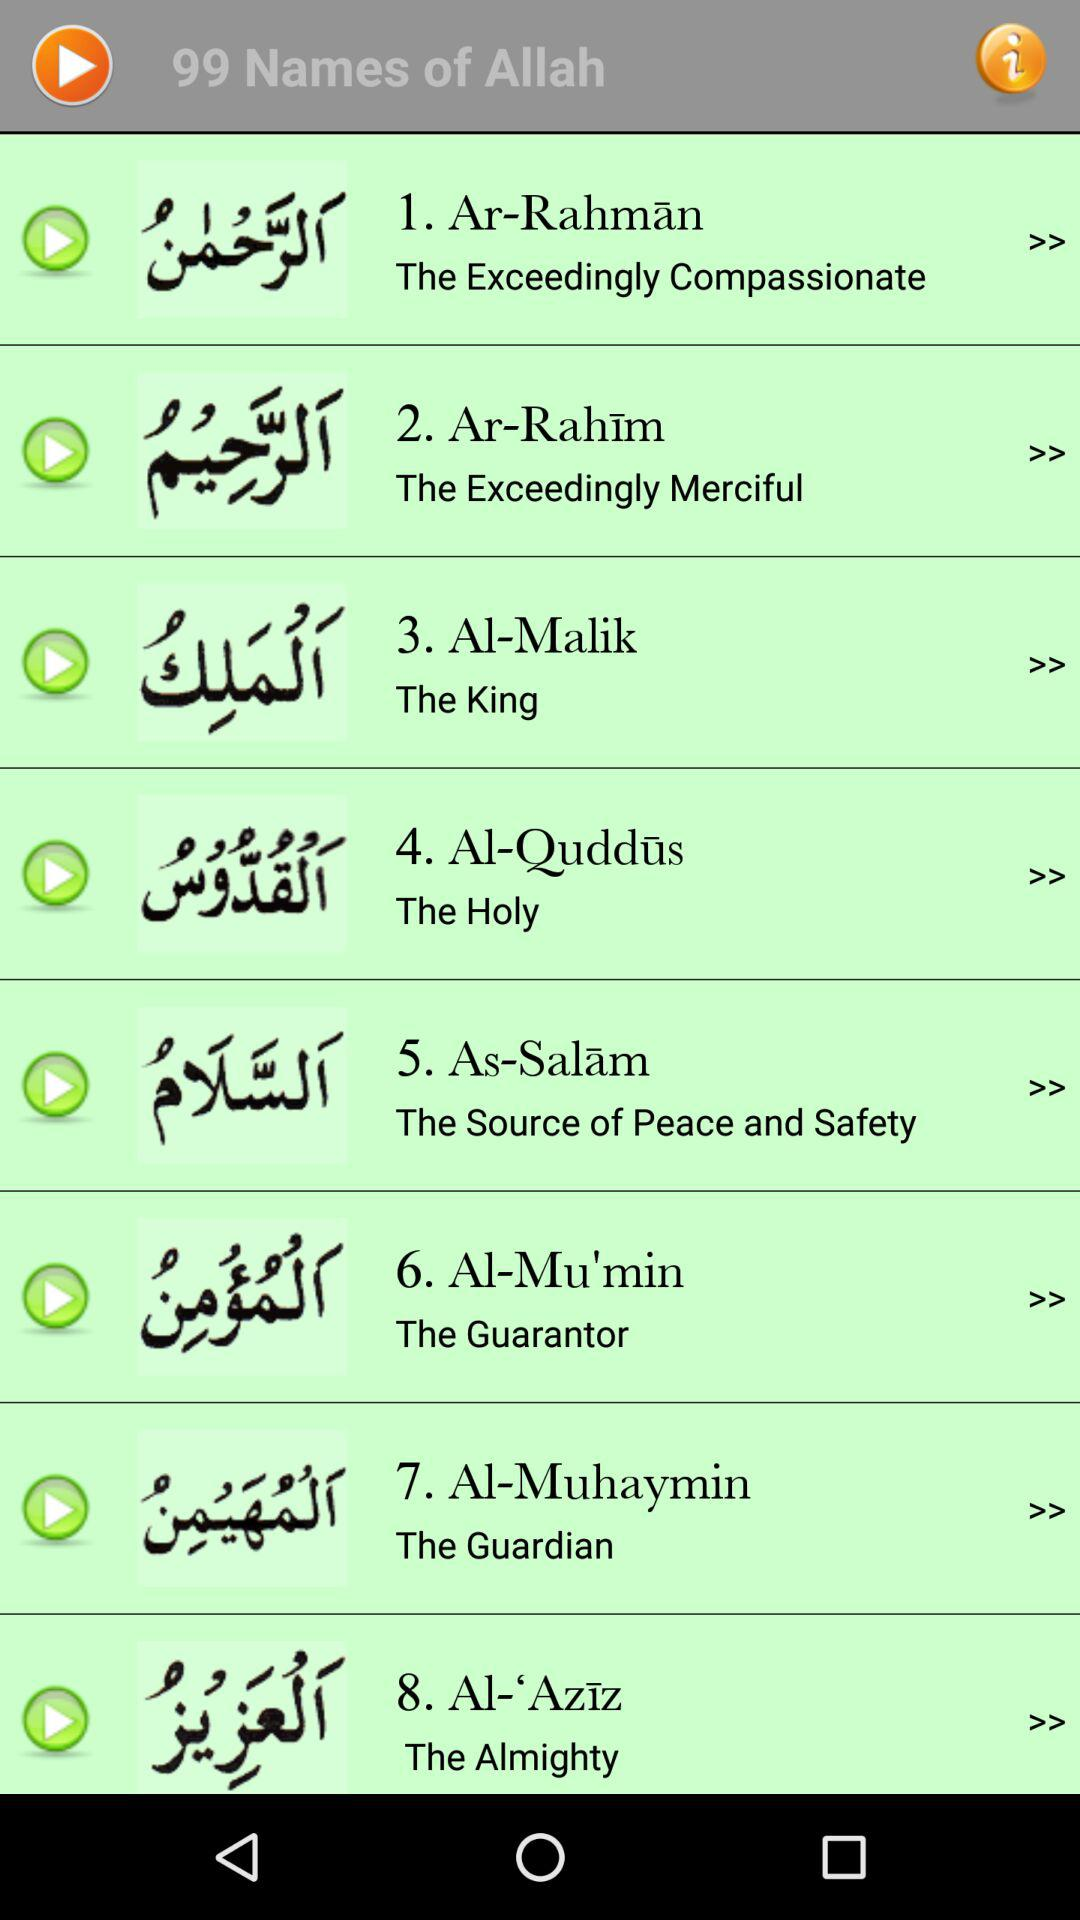How many names of Allah are currently displayed?
Answer the question using a single word or phrase. 8 